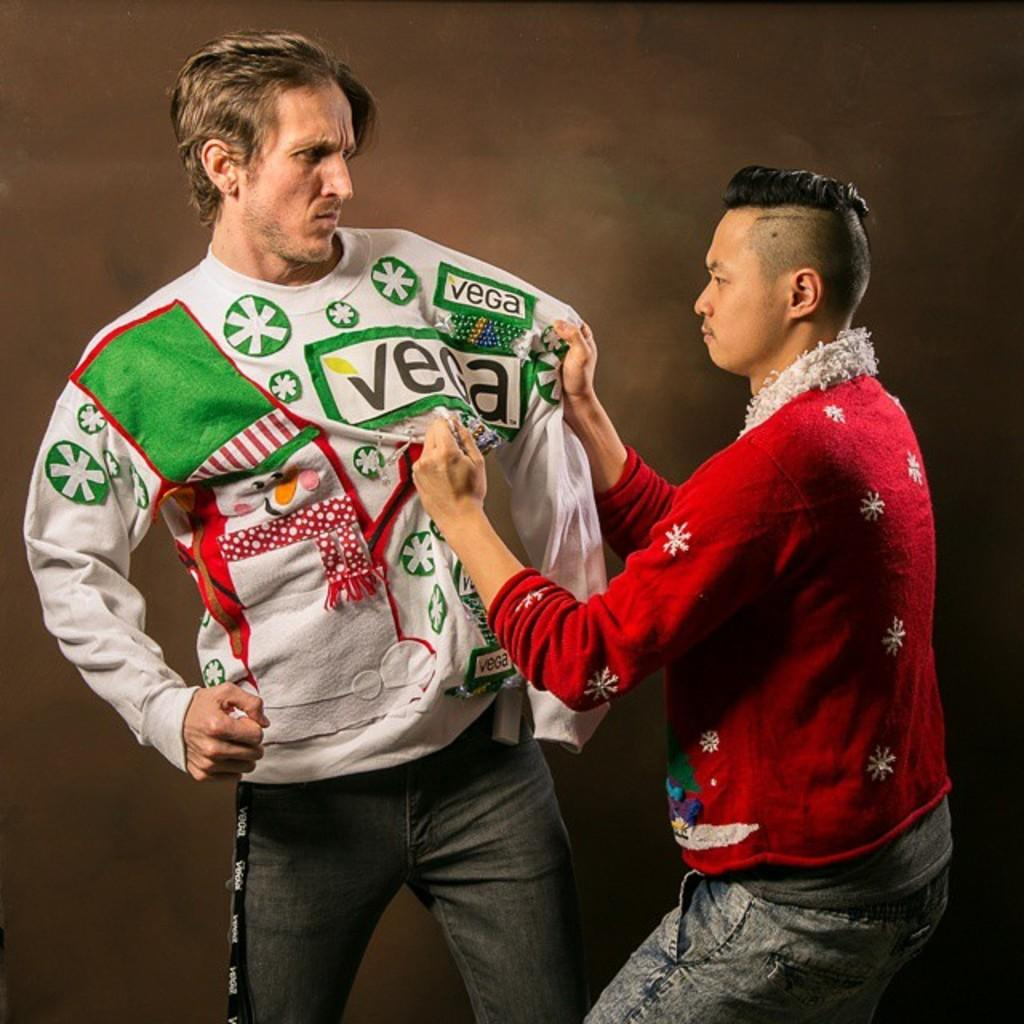<image>
Share a concise interpretation of the image provided. vega shirt being pulled by another person both with angry faces with one about to punch the other 